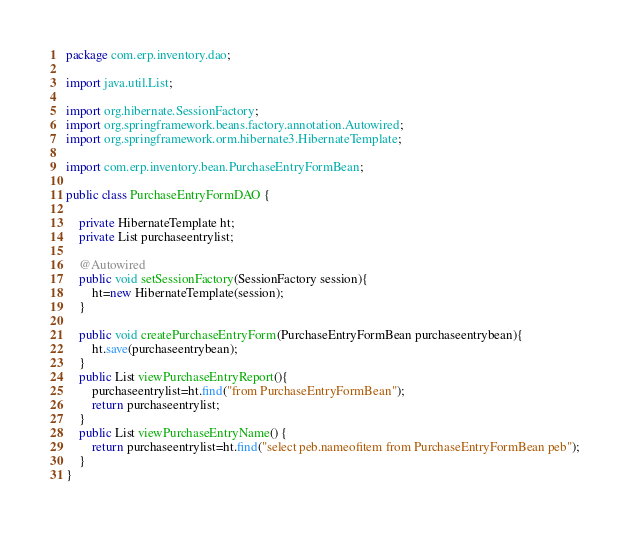<code> <loc_0><loc_0><loc_500><loc_500><_Java_>package com.erp.inventory.dao;

import java.util.List;

import org.hibernate.SessionFactory;
import org.springframework.beans.factory.annotation.Autowired;
import org.springframework.orm.hibernate3.HibernateTemplate;

import com.erp.inventory.bean.PurchaseEntryFormBean;

public class PurchaseEntryFormDAO {

	private HibernateTemplate ht;
	private List purchaseentrylist;
	
	@Autowired
	public void setSessionFactory(SessionFactory session){
		ht=new HibernateTemplate(session);
	}
	
	public void createPurchaseEntryForm(PurchaseEntryFormBean purchaseentrybean){
		ht.save(purchaseentrybean);
	}
	public List viewPurchaseEntryReport(){
		purchaseentrylist=ht.find("from PurchaseEntryFormBean");
		return purchaseentrylist;
	}
	public List viewPurchaseEntryName() {
		return purchaseentrylist=ht.find("select peb.nameofitem from PurchaseEntryFormBean peb");
	}
}
</code> 